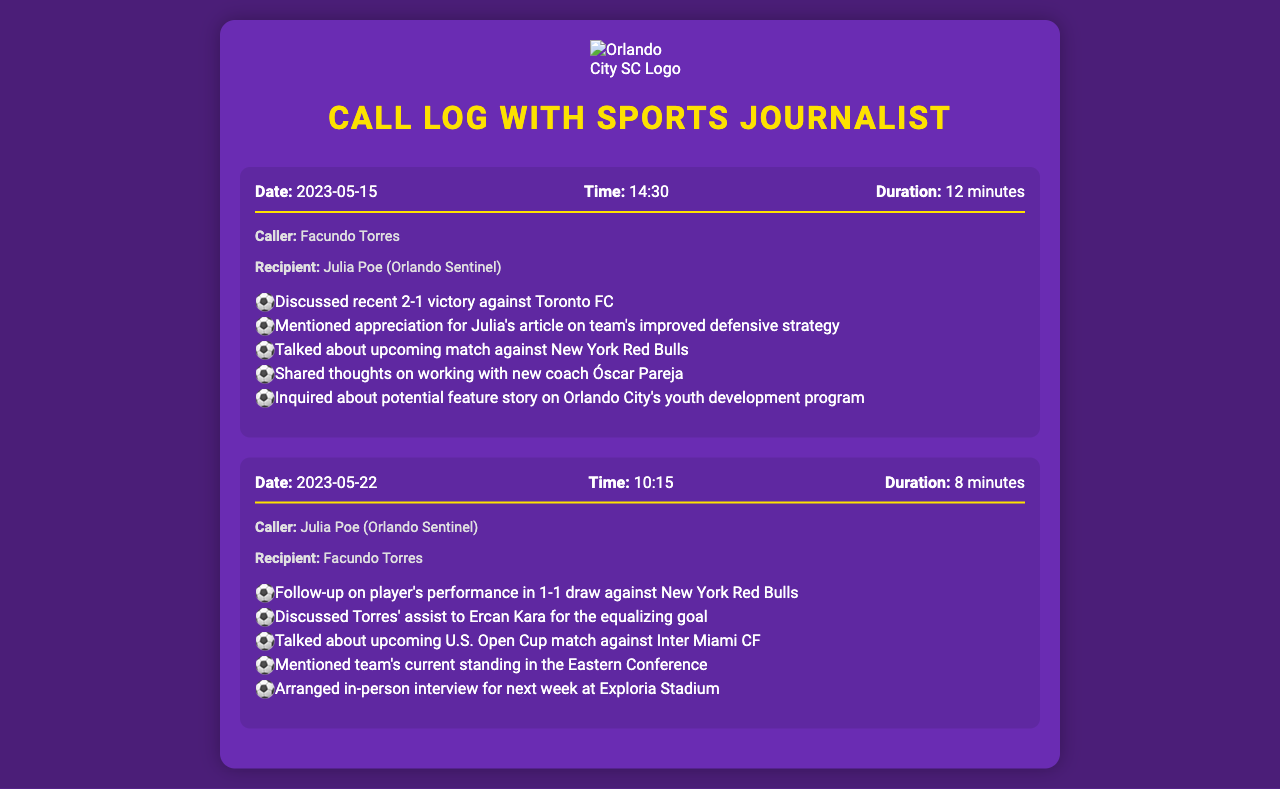what was the recent match result against Toronto FC? The document states that the recent match result was a 2-1 victory against Toronto FC.
Answer: 2-1 victory who did Facundo Torres discuss in the call on May 15? The call on May 15 was with Julia Poe from the Orlando Sentinel.
Answer: Julia Poe what is the upcoming opponent for Orlando City SC mentioned in the call on May 15? Orlando City SC's upcoming opponent mentioned in the call is New York Red Bulls.
Answer: New York Red Bulls how long did the call on May 22 last? The call on May 22 lasted 8 minutes according to the call details.
Answer: 8 minutes who provided an assist for the equalizing goal in the match against New York Red Bulls? Facundo Torres provided an assist to Ercan Kara for the equalizing goal.
Answer: Ercan Kara what match is mentioned as upcoming on May 22? The upcoming match mentioned on May 22 is against Inter Miami CF.
Answer: Inter Miami CF what was discussed regarding the team's strategy in the May 15 call? The call noted appreciation for Julia's article on the team's improved defensive strategy.
Answer: improved defensive strategy who is the new coach mentioned in the May 15 call? The new coach discussed in the call is Óscar Pareja.
Answer: Óscar Pareja 